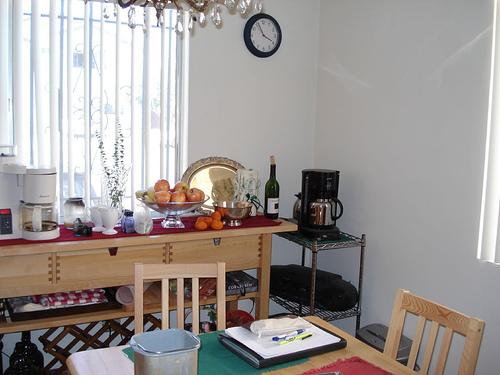What time is on the clock?
Answer briefly. 3:55. How many coffeemakers are in this photo?
Concise answer only. 2. What color is the wall painted?
Concise answer only. White. 